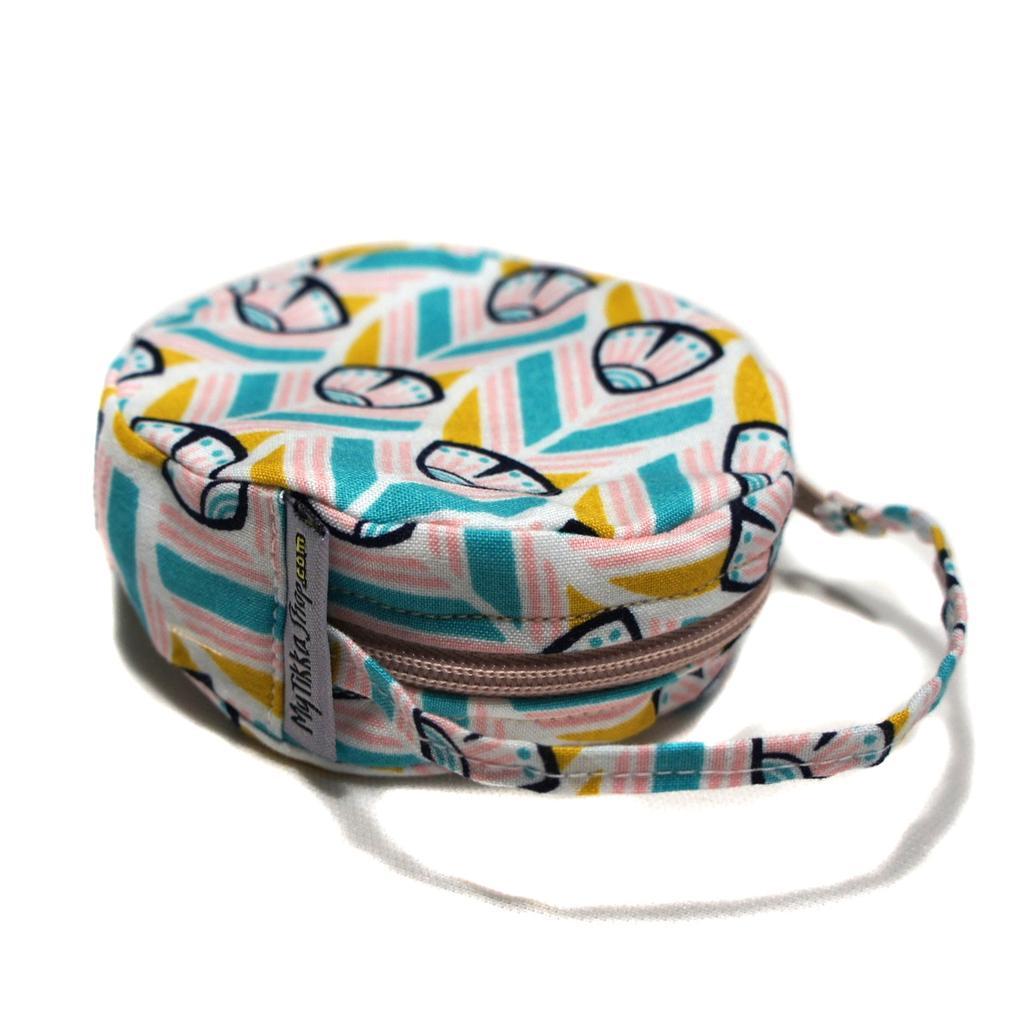Please provide a concise description of this image. In this picture we can see a colorful bag. Remaining portion of the picture is in white color. 